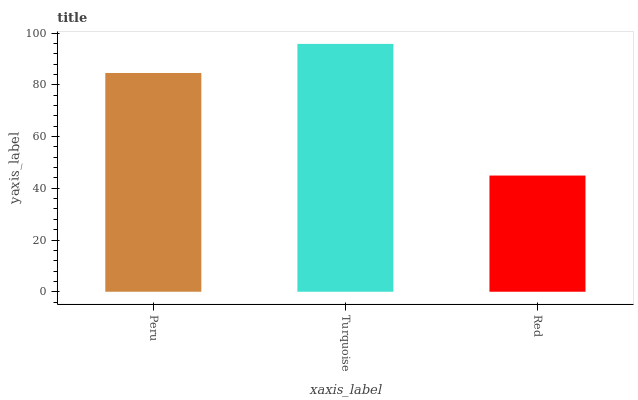Is Red the minimum?
Answer yes or no. Yes. Is Turquoise the maximum?
Answer yes or no. Yes. Is Turquoise the minimum?
Answer yes or no. No. Is Red the maximum?
Answer yes or no. No. Is Turquoise greater than Red?
Answer yes or no. Yes. Is Red less than Turquoise?
Answer yes or no. Yes. Is Red greater than Turquoise?
Answer yes or no. No. Is Turquoise less than Red?
Answer yes or no. No. Is Peru the high median?
Answer yes or no. Yes. Is Peru the low median?
Answer yes or no. Yes. Is Turquoise the high median?
Answer yes or no. No. Is Turquoise the low median?
Answer yes or no. No. 